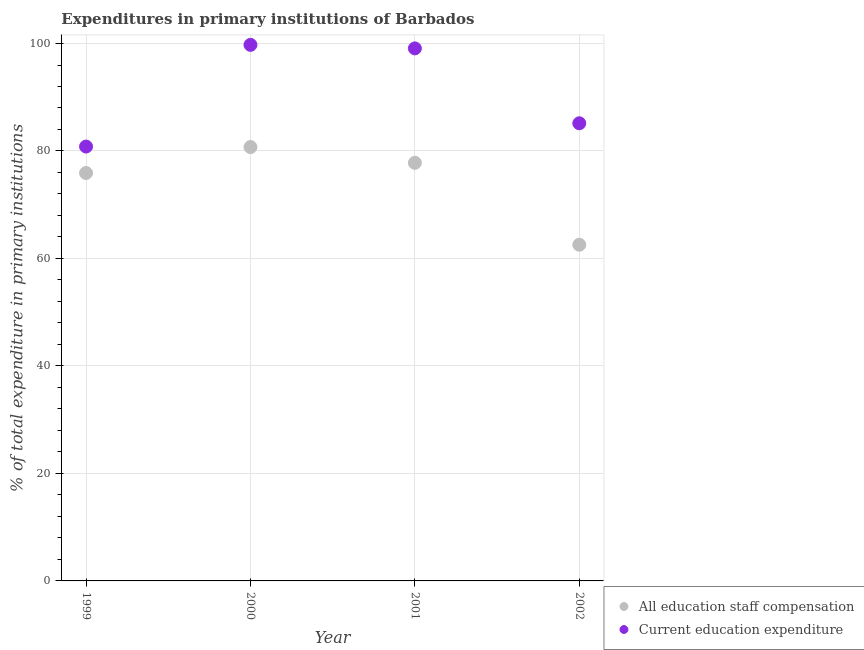What is the expenditure in education in 2001?
Your response must be concise. 99.09. Across all years, what is the maximum expenditure in education?
Give a very brief answer. 99.75. Across all years, what is the minimum expenditure in staff compensation?
Your response must be concise. 62.55. In which year was the expenditure in staff compensation maximum?
Give a very brief answer. 2000. What is the total expenditure in staff compensation in the graph?
Provide a short and direct response. 296.99. What is the difference between the expenditure in education in 1999 and that in 2000?
Provide a succinct answer. -18.92. What is the difference between the expenditure in education in 2002 and the expenditure in staff compensation in 2000?
Offer a terse response. 4.42. What is the average expenditure in staff compensation per year?
Offer a terse response. 74.25. In the year 2000, what is the difference between the expenditure in education and expenditure in staff compensation?
Provide a short and direct response. 19.01. What is the ratio of the expenditure in education in 1999 to that in 2001?
Keep it short and to the point. 0.82. What is the difference between the highest and the second highest expenditure in education?
Provide a succinct answer. 0.65. What is the difference between the highest and the lowest expenditure in education?
Provide a succinct answer. 18.92. In how many years, is the expenditure in staff compensation greater than the average expenditure in staff compensation taken over all years?
Make the answer very short. 3. Is the sum of the expenditure in staff compensation in 2000 and 2002 greater than the maximum expenditure in education across all years?
Offer a very short reply. Yes. Is the expenditure in staff compensation strictly greater than the expenditure in education over the years?
Provide a succinct answer. No. How many dotlines are there?
Offer a terse response. 2. Does the graph contain grids?
Make the answer very short. Yes. Where does the legend appear in the graph?
Your answer should be very brief. Bottom right. What is the title of the graph?
Your response must be concise. Expenditures in primary institutions of Barbados. What is the label or title of the X-axis?
Provide a short and direct response. Year. What is the label or title of the Y-axis?
Keep it short and to the point. % of total expenditure in primary institutions. What is the % of total expenditure in primary institutions of All education staff compensation in 1999?
Provide a short and direct response. 75.91. What is the % of total expenditure in primary institutions of Current education expenditure in 1999?
Ensure brevity in your answer.  80.83. What is the % of total expenditure in primary institutions of All education staff compensation in 2000?
Keep it short and to the point. 80.73. What is the % of total expenditure in primary institutions of Current education expenditure in 2000?
Make the answer very short. 99.75. What is the % of total expenditure in primary institutions of All education staff compensation in 2001?
Keep it short and to the point. 77.8. What is the % of total expenditure in primary institutions of Current education expenditure in 2001?
Provide a short and direct response. 99.09. What is the % of total expenditure in primary institutions of All education staff compensation in 2002?
Offer a terse response. 62.55. What is the % of total expenditure in primary institutions of Current education expenditure in 2002?
Your answer should be compact. 85.16. Across all years, what is the maximum % of total expenditure in primary institutions in All education staff compensation?
Keep it short and to the point. 80.73. Across all years, what is the maximum % of total expenditure in primary institutions in Current education expenditure?
Provide a short and direct response. 99.75. Across all years, what is the minimum % of total expenditure in primary institutions in All education staff compensation?
Ensure brevity in your answer.  62.55. Across all years, what is the minimum % of total expenditure in primary institutions in Current education expenditure?
Keep it short and to the point. 80.83. What is the total % of total expenditure in primary institutions of All education staff compensation in the graph?
Your answer should be compact. 296.99. What is the total % of total expenditure in primary institutions of Current education expenditure in the graph?
Provide a succinct answer. 364.82. What is the difference between the % of total expenditure in primary institutions of All education staff compensation in 1999 and that in 2000?
Give a very brief answer. -4.83. What is the difference between the % of total expenditure in primary institutions in Current education expenditure in 1999 and that in 2000?
Offer a very short reply. -18.92. What is the difference between the % of total expenditure in primary institutions of All education staff compensation in 1999 and that in 2001?
Ensure brevity in your answer.  -1.89. What is the difference between the % of total expenditure in primary institutions in Current education expenditure in 1999 and that in 2001?
Provide a succinct answer. -18.27. What is the difference between the % of total expenditure in primary institutions in All education staff compensation in 1999 and that in 2002?
Make the answer very short. 13.35. What is the difference between the % of total expenditure in primary institutions in Current education expenditure in 1999 and that in 2002?
Your response must be concise. -4.33. What is the difference between the % of total expenditure in primary institutions in All education staff compensation in 2000 and that in 2001?
Make the answer very short. 2.94. What is the difference between the % of total expenditure in primary institutions in Current education expenditure in 2000 and that in 2001?
Ensure brevity in your answer.  0.65. What is the difference between the % of total expenditure in primary institutions in All education staff compensation in 2000 and that in 2002?
Offer a very short reply. 18.18. What is the difference between the % of total expenditure in primary institutions of Current education expenditure in 2000 and that in 2002?
Your response must be concise. 14.59. What is the difference between the % of total expenditure in primary institutions in All education staff compensation in 2001 and that in 2002?
Offer a very short reply. 15.24. What is the difference between the % of total expenditure in primary institutions of Current education expenditure in 2001 and that in 2002?
Keep it short and to the point. 13.94. What is the difference between the % of total expenditure in primary institutions in All education staff compensation in 1999 and the % of total expenditure in primary institutions in Current education expenditure in 2000?
Keep it short and to the point. -23.84. What is the difference between the % of total expenditure in primary institutions of All education staff compensation in 1999 and the % of total expenditure in primary institutions of Current education expenditure in 2001?
Keep it short and to the point. -23.19. What is the difference between the % of total expenditure in primary institutions in All education staff compensation in 1999 and the % of total expenditure in primary institutions in Current education expenditure in 2002?
Provide a short and direct response. -9.25. What is the difference between the % of total expenditure in primary institutions in All education staff compensation in 2000 and the % of total expenditure in primary institutions in Current education expenditure in 2001?
Your answer should be very brief. -18.36. What is the difference between the % of total expenditure in primary institutions of All education staff compensation in 2000 and the % of total expenditure in primary institutions of Current education expenditure in 2002?
Your answer should be compact. -4.42. What is the difference between the % of total expenditure in primary institutions in All education staff compensation in 2001 and the % of total expenditure in primary institutions in Current education expenditure in 2002?
Provide a short and direct response. -7.36. What is the average % of total expenditure in primary institutions of All education staff compensation per year?
Ensure brevity in your answer.  74.25. What is the average % of total expenditure in primary institutions of Current education expenditure per year?
Offer a very short reply. 91.21. In the year 1999, what is the difference between the % of total expenditure in primary institutions of All education staff compensation and % of total expenditure in primary institutions of Current education expenditure?
Your answer should be compact. -4.92. In the year 2000, what is the difference between the % of total expenditure in primary institutions in All education staff compensation and % of total expenditure in primary institutions in Current education expenditure?
Offer a very short reply. -19.01. In the year 2001, what is the difference between the % of total expenditure in primary institutions in All education staff compensation and % of total expenditure in primary institutions in Current education expenditure?
Offer a very short reply. -21.29. In the year 2002, what is the difference between the % of total expenditure in primary institutions in All education staff compensation and % of total expenditure in primary institutions in Current education expenditure?
Keep it short and to the point. -22.6. What is the ratio of the % of total expenditure in primary institutions of All education staff compensation in 1999 to that in 2000?
Provide a succinct answer. 0.94. What is the ratio of the % of total expenditure in primary institutions in Current education expenditure in 1999 to that in 2000?
Make the answer very short. 0.81. What is the ratio of the % of total expenditure in primary institutions in All education staff compensation in 1999 to that in 2001?
Keep it short and to the point. 0.98. What is the ratio of the % of total expenditure in primary institutions in Current education expenditure in 1999 to that in 2001?
Keep it short and to the point. 0.82. What is the ratio of the % of total expenditure in primary institutions of All education staff compensation in 1999 to that in 2002?
Give a very brief answer. 1.21. What is the ratio of the % of total expenditure in primary institutions of Current education expenditure in 1999 to that in 2002?
Provide a succinct answer. 0.95. What is the ratio of the % of total expenditure in primary institutions in All education staff compensation in 2000 to that in 2001?
Your answer should be very brief. 1.04. What is the ratio of the % of total expenditure in primary institutions of Current education expenditure in 2000 to that in 2001?
Provide a short and direct response. 1.01. What is the ratio of the % of total expenditure in primary institutions in All education staff compensation in 2000 to that in 2002?
Give a very brief answer. 1.29. What is the ratio of the % of total expenditure in primary institutions of Current education expenditure in 2000 to that in 2002?
Provide a succinct answer. 1.17. What is the ratio of the % of total expenditure in primary institutions of All education staff compensation in 2001 to that in 2002?
Provide a succinct answer. 1.24. What is the ratio of the % of total expenditure in primary institutions in Current education expenditure in 2001 to that in 2002?
Give a very brief answer. 1.16. What is the difference between the highest and the second highest % of total expenditure in primary institutions of All education staff compensation?
Your answer should be compact. 2.94. What is the difference between the highest and the second highest % of total expenditure in primary institutions in Current education expenditure?
Your answer should be compact. 0.65. What is the difference between the highest and the lowest % of total expenditure in primary institutions in All education staff compensation?
Your answer should be compact. 18.18. What is the difference between the highest and the lowest % of total expenditure in primary institutions in Current education expenditure?
Offer a very short reply. 18.92. 